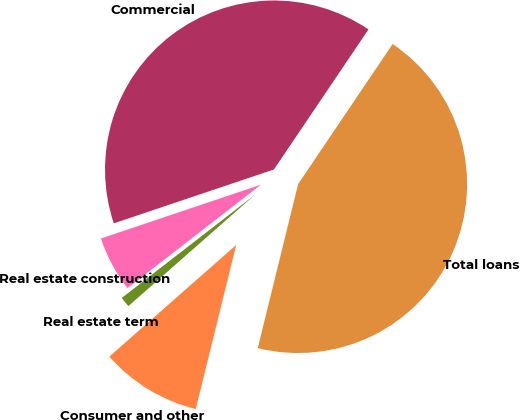<chart> <loc_0><loc_0><loc_500><loc_500><pie_chart><fcel>Commercial<fcel>Real estate construction<fcel>Real estate term<fcel>Consumer and other<fcel>Total loans<nl><fcel>39.61%<fcel>5.33%<fcel>0.99%<fcel>9.67%<fcel>44.39%<nl></chart> 